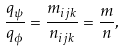Convert formula to latex. <formula><loc_0><loc_0><loc_500><loc_500>\frac { q _ { \psi } } { q _ { \phi } } = \frac { m _ { i j k } } { n _ { i j k } } = \frac { m } { n } ,</formula> 